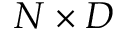Convert formula to latex. <formula><loc_0><loc_0><loc_500><loc_500>N \times D</formula> 